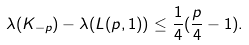<formula> <loc_0><loc_0><loc_500><loc_500>\lambda ( K _ { - p } ) - \lambda ( L ( p , 1 ) ) \leq \frac { 1 } { 4 } ( \frac { p } { 4 } - 1 ) .</formula> 